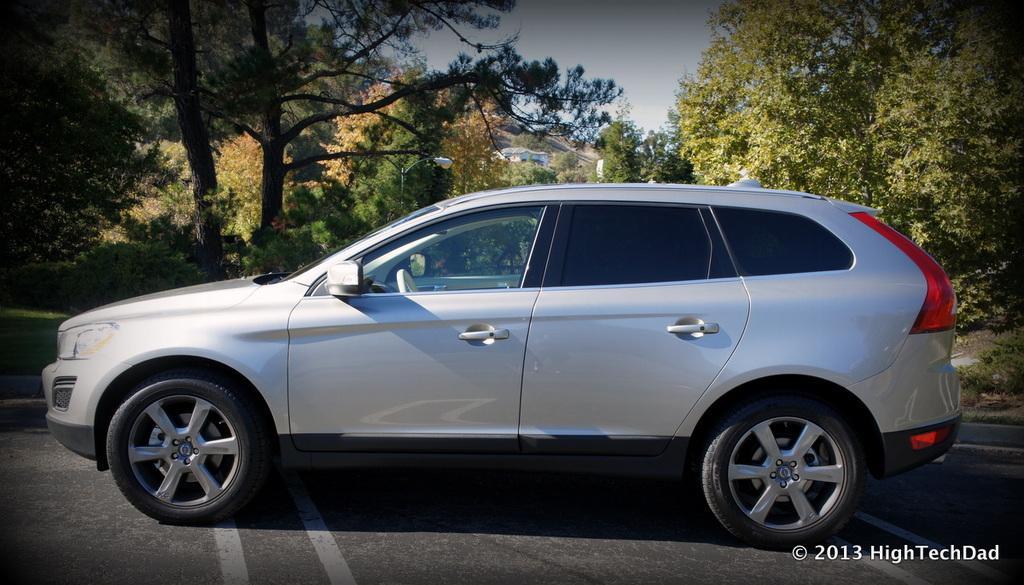In one or two sentences, can you explain what this image depicts? In this image there is a vehicle on the road, behind the vehicle there are trees, a street light and there is a building. In the background there is the sky. 